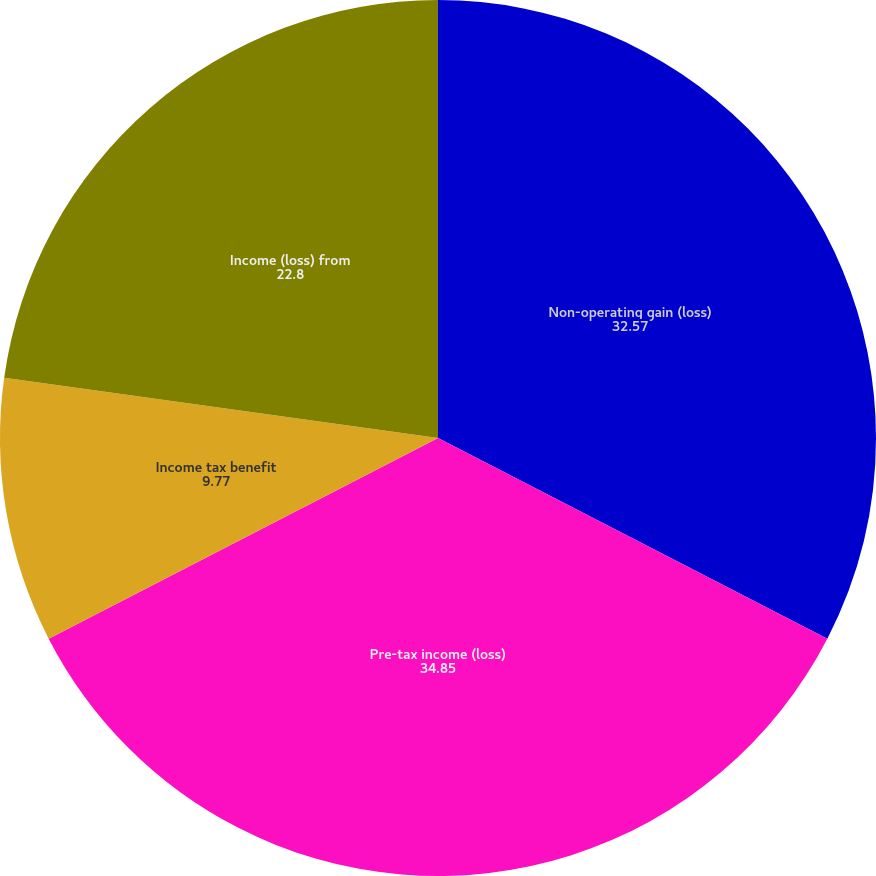Convert chart. <chart><loc_0><loc_0><loc_500><loc_500><pie_chart><fcel>Non-operating gain (loss)<fcel>Pre-tax income (loss)<fcel>Income tax benefit<fcel>Income (loss) from<nl><fcel>32.57%<fcel>34.85%<fcel>9.77%<fcel>22.8%<nl></chart> 